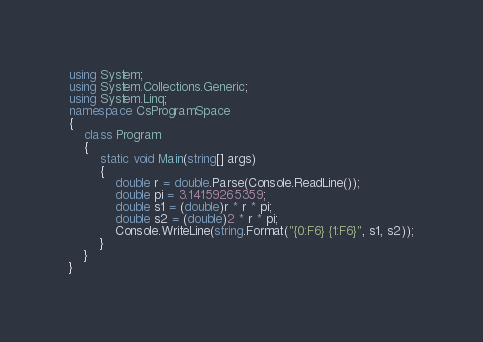Convert code to text. <code><loc_0><loc_0><loc_500><loc_500><_C#_>using System;
using System.Collections.Generic;
using System.Linq;
namespace CsProgramSpace
{
    class Program
    {
        static void Main(string[] args)
        {
            double r = double.Parse(Console.ReadLine());
            double pi = 3.14159265359;
            double s1 = (double)r * r * pi;
            double s2 = (double)2 * r * pi;
            Console.WriteLine(string.Format("{0:F6} {1:F6}", s1, s2));
        }
    }
}
</code> 